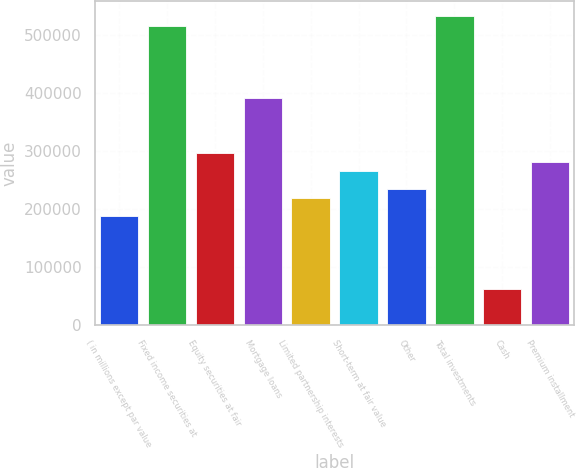Convert chart. <chart><loc_0><loc_0><loc_500><loc_500><bar_chart><fcel>( in millions except par value<fcel>Fixed income securities at<fcel>Equity securities at fair<fcel>Mortgage loans<fcel>Limited partnership interests<fcel>Short-term at fair value<fcel>Other<fcel>Total investments<fcel>Cash<fcel>Premium installment<nl><fcel>187688<fcel>516126<fcel>297167<fcel>391006<fcel>218968<fcel>265887<fcel>234608<fcel>531766<fcel>62568.6<fcel>281527<nl></chart> 